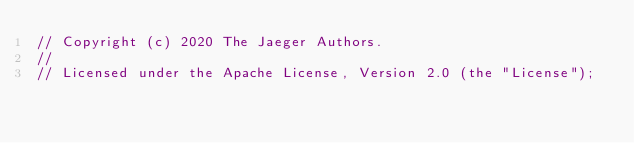<code> <loc_0><loc_0><loc_500><loc_500><_Go_>// Copyright (c) 2020 The Jaeger Authors.
//
// Licensed under the Apache License, Version 2.0 (the "License");</code> 